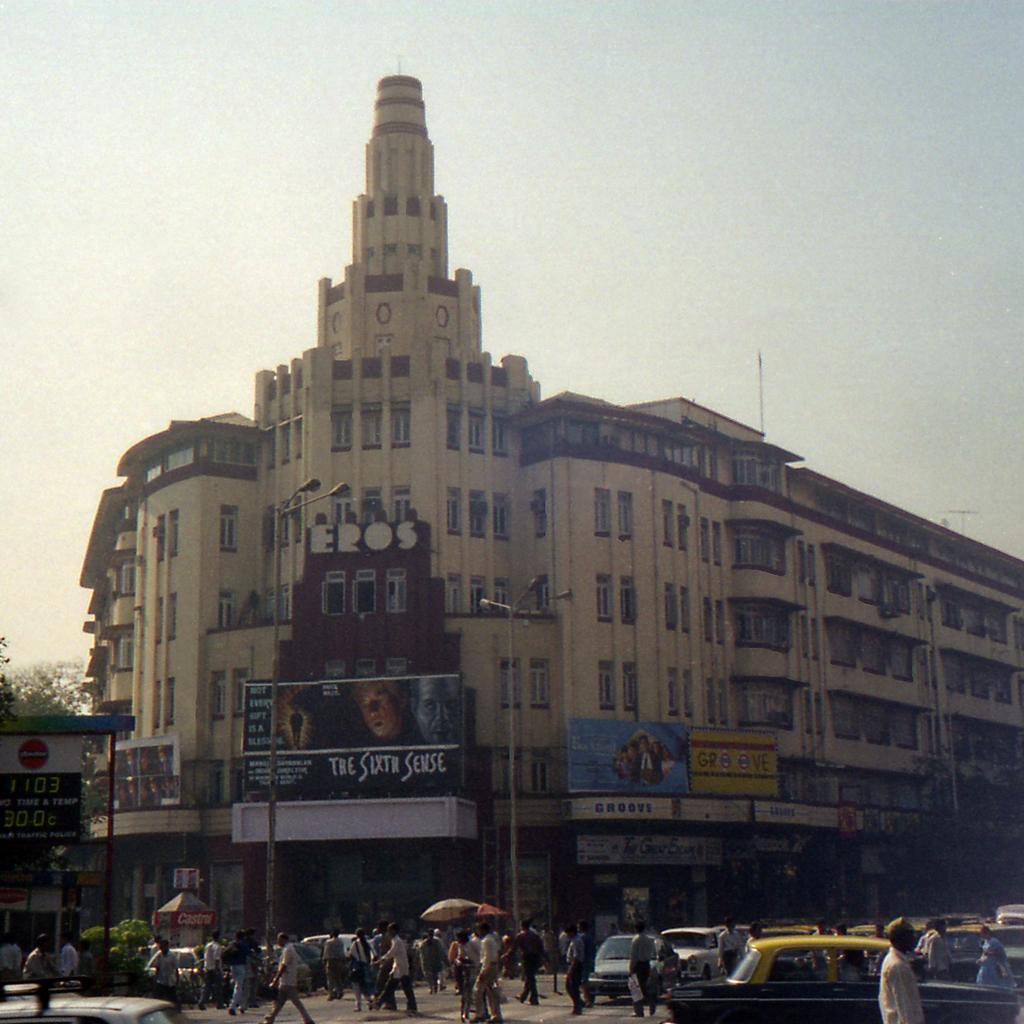What are the people in the image doing? There are many people walking on the road in the image. What else is happening on the road? There are cars moving in the image. What can be seen in the background of the image? There is a building with many windows in the background. What type of establishments are located below the building? There are stores below the building. What is visible above the building? The sky is visible above the building. What type of hair can be seen on the field in the image? There is no field or hair present in the image. What sound does the alarm make in the image? There is no alarm present in the image. 